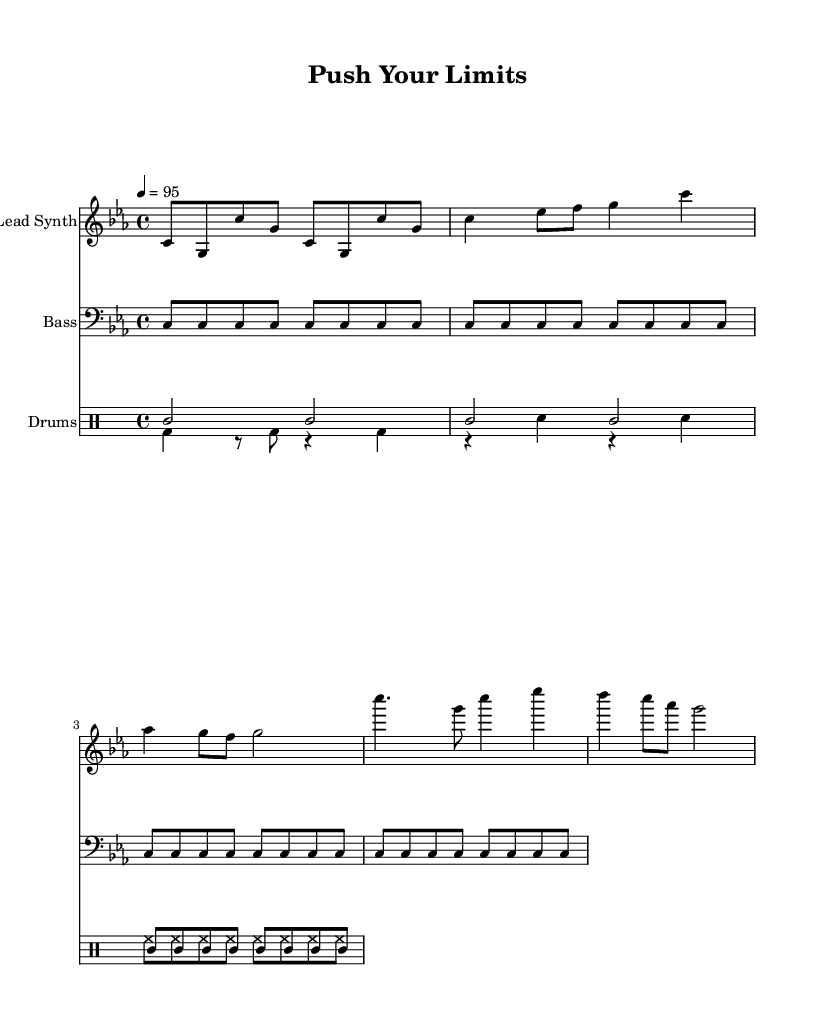What is the key signature of this music? The key signature is C minor, which has three flats (B flat, E flat, and A flat) that are indicated at the beginning of the staff.
Answer: C minor What is the time signature of the piece? The time signature is 4/4, meaning there are four beats in each measure and the quarter note gets one beat, as shown prominently at the beginning of the score.
Answer: 4/4 What is the tempo marking of the piece? The tempo marking is 4 = 95, indicating that there are 95 beats per minute, which guides the performance speed of the piece.
Answer: 95 How many measures are in the bass line? The bass line consists of four measures, as it repeats its pattern throughout these four sections.
Answer: 4 Which instrument plays the lead synth part? The lead synth part is performed by the "Lead Synth" as identified by the instrument name labeled at the top of the corresponding staff.
Answer: Lead Synth What type of rhythm does the drum part primarily use? The drum part primarily uses a combination of quarter notes and eighth notes, indicated by the rhythm notation in the drum staff, creating a driving beat typical in hip hop.
Answer: Combination of quarter notes and eighth notes What main theme does the chorus focus on in this motivational rap? The chorus focuses on pushing physical limits, as implied by the title "Push Your Limits," which evokes themes of determination and athletic training.
Answer: Pushing physical limits 